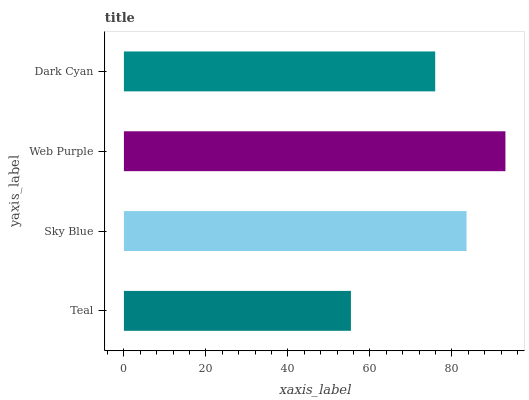Is Teal the minimum?
Answer yes or no. Yes. Is Web Purple the maximum?
Answer yes or no. Yes. Is Sky Blue the minimum?
Answer yes or no. No. Is Sky Blue the maximum?
Answer yes or no. No. Is Sky Blue greater than Teal?
Answer yes or no. Yes. Is Teal less than Sky Blue?
Answer yes or no. Yes. Is Teal greater than Sky Blue?
Answer yes or no. No. Is Sky Blue less than Teal?
Answer yes or no. No. Is Sky Blue the high median?
Answer yes or no. Yes. Is Dark Cyan the low median?
Answer yes or no. Yes. Is Teal the high median?
Answer yes or no. No. Is Web Purple the low median?
Answer yes or no. No. 